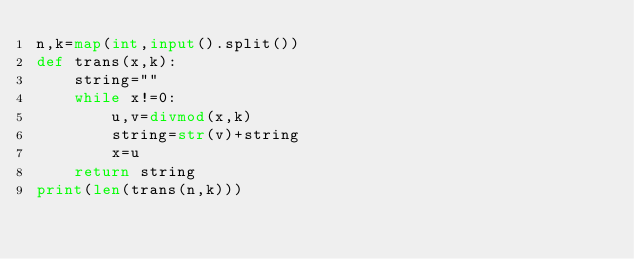Convert code to text. <code><loc_0><loc_0><loc_500><loc_500><_Python_>n,k=map(int,input().split())
def trans(x,k):
    string=""
    while x!=0:
        u,v=divmod(x,k)
        string=str(v)+string
        x=u
    return string
print(len(trans(n,k)))</code> 